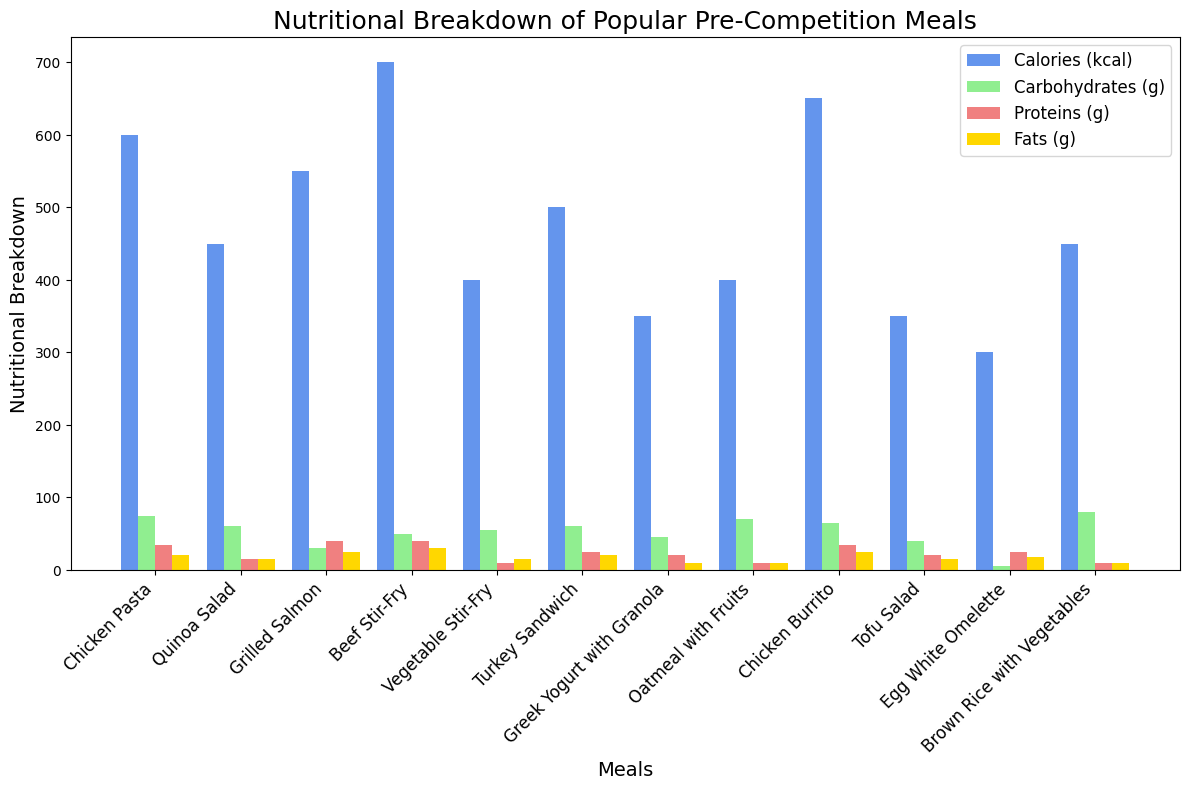Which meal has the highest calories? Check the tallest blue bar representing calories. The Beef Stir-Fry is the meal with the highest calories.
Answer: Beef Stir-Fry Which meal has the lowest amount of proteins? Identify the shortest red bar representing proteins for each meal. The Vegetable Stir-Fry has the shortest red bar.
Answer: Vegetable Stir-Fry What is the total amount of carbohydrates in the Chicken Pasta and Quinoa Salad together? Sum the carbohydrate grams from the Chicken Pasta (75g) and Quinoa Salad (60g). 75 + 60 = 135g
Answer: 135g Which meal has more fats, Chicken Burrito or Grilled Salmon? Compare the height of the yellow bar for both meals. The Chicken Burrito and Grilled Salmon both have the same fat content, 25g.
Answer: They have the same amount of fats, 25g Rank the meals in decreasing order of protein content. Arrange meals from the highest to the lowest red bar height. The order is Beef Stir-Fry, Grilled Salmon, Chicken Pasta, Chicken Burrito, Turkey Sandwich, Greek Yogurt with Granola, Tofu Salad, Egg White Omelette, Quinoa Salad, Vegetable Stir-Fry, Oatmeal with Fruits, Brown Rice with Vegetables.
Answer: Beef Stir-Fry, Grilled Salmon, Chicken Pasta, Chicken Burrito, Turkey Sandwich, Greek Yogurt with Granola, Tofu Salad, Egg White Omelette, Quinoa Salad, Vegetable Stir-Fry, Oatmeal with Fruits, Brown Rice with Vegetables Which meal has the highest carbohydrate content? Check the tallest green bar representing carbohydrates. The Brown Rice with Vegetables has the highest carbohydrate content.
Answer: Brown Rice with Vegetables What is the average amount of fats in Greek Yogurt with Granola, Oatmeal with Fruits, and Tofu Salad? Add up the fats (10g + 10g + 15g = 35g) and divide by the number of meals (3). 35 / 3 = 11.67g
Answer: 11.67g How much more calories does Beef Stir-Fry have compared to Egg White Omelette? Subtract the calories of Egg White Omelette (300kcal) from the calories of Beef Stir-Fry (700kcal). 700 - 300 = 400kcal
Answer: 400kcal 